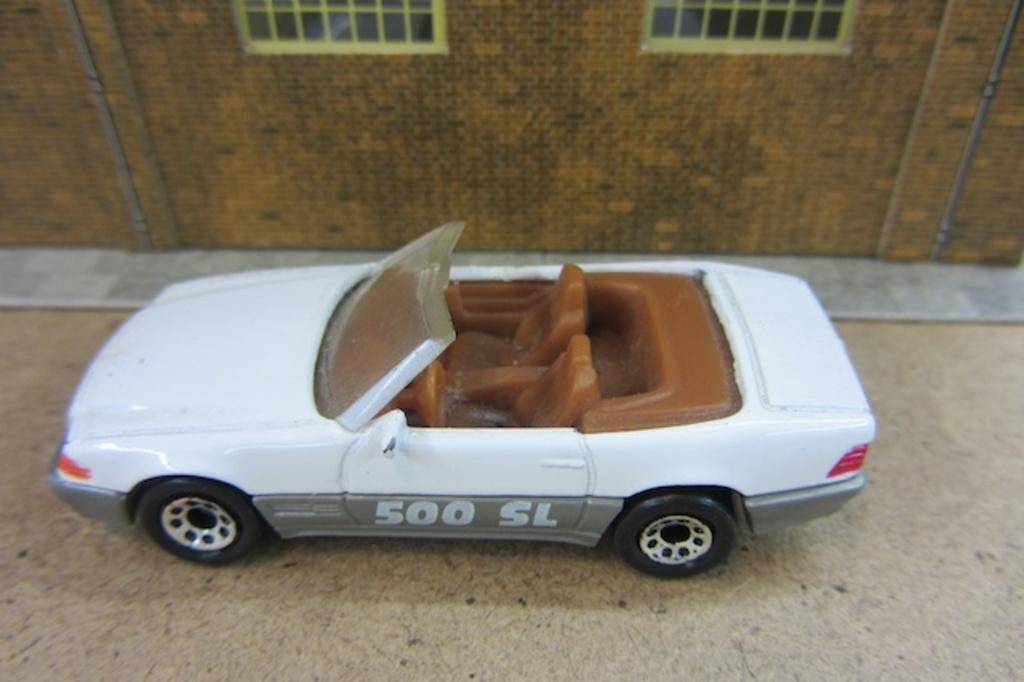What object is present in the image that resembles a vehicle? There is a toy car in the image. What type of structure is visible in the image? There is a wall in the image. How many windows are present on the wall in the image? The wall has two windows. What type of decision is the toy car making in the image? The toy car is not capable of making decisions, as it is an inanimate object. Can you see a zipper on the toy car in the image? There is no zipper present on the toy car in the image, as it is not a clothing item. 